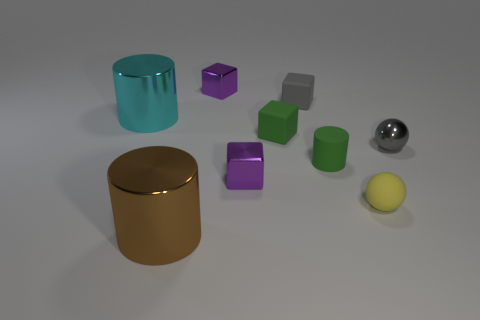The shiny object to the left of the shiny cylinder in front of the tiny yellow ball is what color?
Keep it short and to the point. Cyan. What is the shape of the purple object in front of the tiny metal object on the right side of the green rubber object that is in front of the gray shiny thing?
Your answer should be very brief. Cube. What number of balls are made of the same material as the brown thing?
Your answer should be very brief. 1. There is a big object behind the large brown cylinder; what number of large objects are to the left of it?
Make the answer very short. 0. How many small brown matte blocks are there?
Provide a short and direct response. 0. Do the tiny green cube and the small sphere in front of the small gray metallic object have the same material?
Provide a short and direct response. Yes. Does the matte object behind the cyan metal object have the same color as the tiny shiny ball?
Offer a very short reply. Yes. There is a cylinder that is both on the left side of the small green cylinder and behind the brown thing; what material is it?
Provide a short and direct response. Metal. How big is the gray rubber thing?
Your answer should be compact. Small. Is the color of the matte cylinder the same as the rubber thing to the left of the small gray matte object?
Give a very brief answer. Yes. 